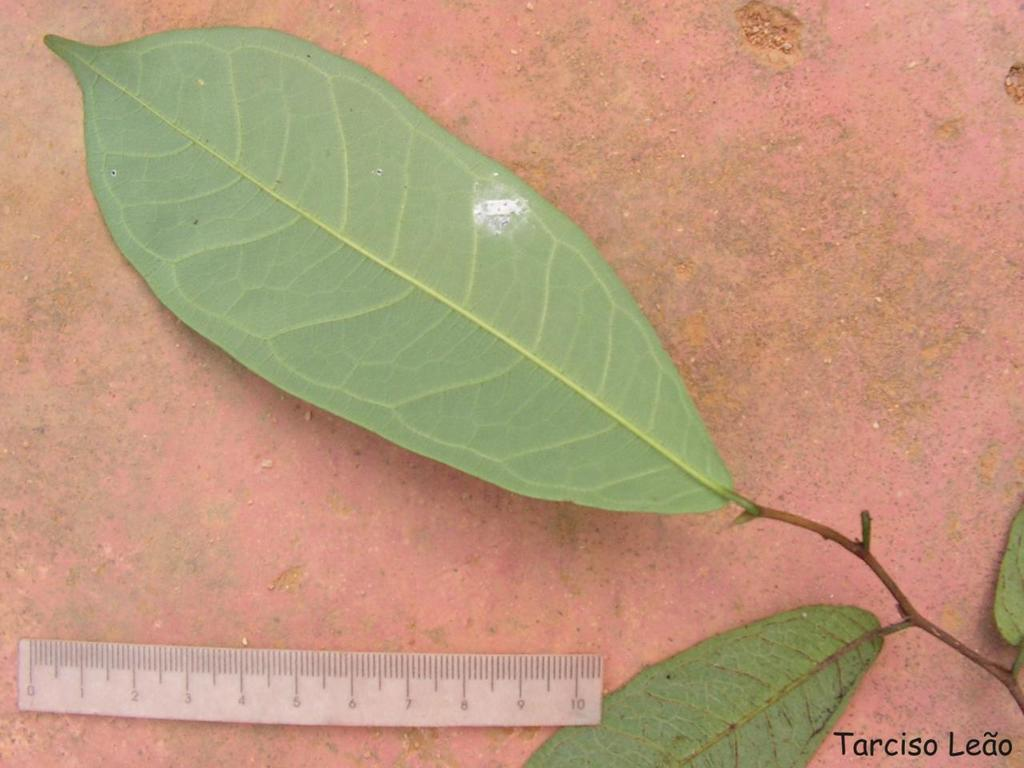Provide a one-sentence caption for the provided image. The leaf pictured above the ruler better not be too long, as the ruler only goes up to 10cm. 